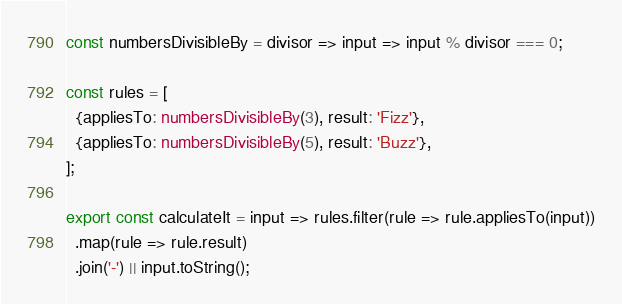<code> <loc_0><loc_0><loc_500><loc_500><_TypeScript_>const numbersDivisibleBy = divisor => input => input % divisor === 0;

const rules = [
  {appliesTo: numbersDivisibleBy(3), result: 'Fizz'},
  {appliesTo: numbersDivisibleBy(5), result: 'Buzz'},
];

export const calculateIt = input => rules.filter(rule => rule.appliesTo(input))
  .map(rule => rule.result)
  .join('-') || input.toString();
</code> 